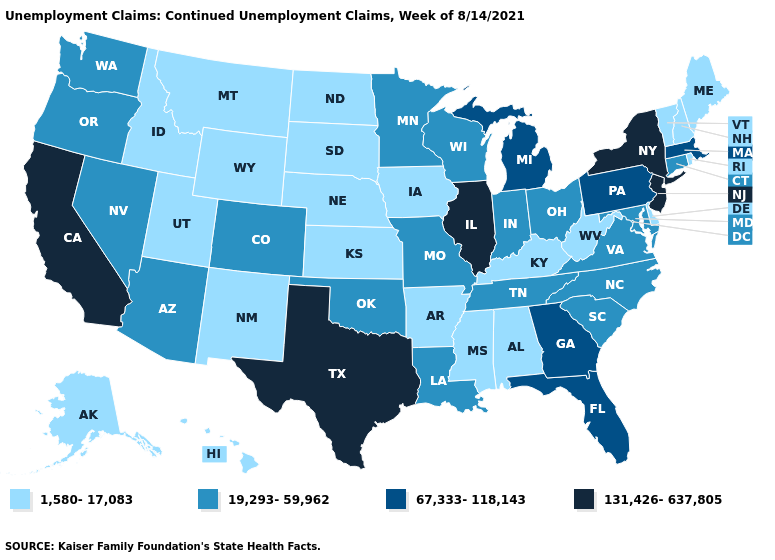Which states hav the highest value in the Northeast?
Answer briefly. New Jersey, New York. What is the lowest value in the USA?
Quick response, please. 1,580-17,083. What is the lowest value in the Northeast?
Give a very brief answer. 1,580-17,083. Does Texas have the highest value in the USA?
Give a very brief answer. Yes. Does Vermont have the lowest value in the Northeast?
Give a very brief answer. Yes. Does Colorado have a higher value than Arkansas?
Quick response, please. Yes. What is the lowest value in the USA?
Be succinct. 1,580-17,083. Which states have the lowest value in the West?
Be succinct. Alaska, Hawaii, Idaho, Montana, New Mexico, Utah, Wyoming. Which states have the lowest value in the USA?
Quick response, please. Alabama, Alaska, Arkansas, Delaware, Hawaii, Idaho, Iowa, Kansas, Kentucky, Maine, Mississippi, Montana, Nebraska, New Hampshire, New Mexico, North Dakota, Rhode Island, South Dakota, Utah, Vermont, West Virginia, Wyoming. Name the states that have a value in the range 1,580-17,083?
Quick response, please. Alabama, Alaska, Arkansas, Delaware, Hawaii, Idaho, Iowa, Kansas, Kentucky, Maine, Mississippi, Montana, Nebraska, New Hampshire, New Mexico, North Dakota, Rhode Island, South Dakota, Utah, Vermont, West Virginia, Wyoming. Does Indiana have the highest value in the USA?
Give a very brief answer. No. Among the states that border Louisiana , does Texas have the highest value?
Be succinct. Yes. What is the lowest value in the USA?
Quick response, please. 1,580-17,083. Which states have the highest value in the USA?
Answer briefly. California, Illinois, New Jersey, New York, Texas. How many symbols are there in the legend?
Write a very short answer. 4. 